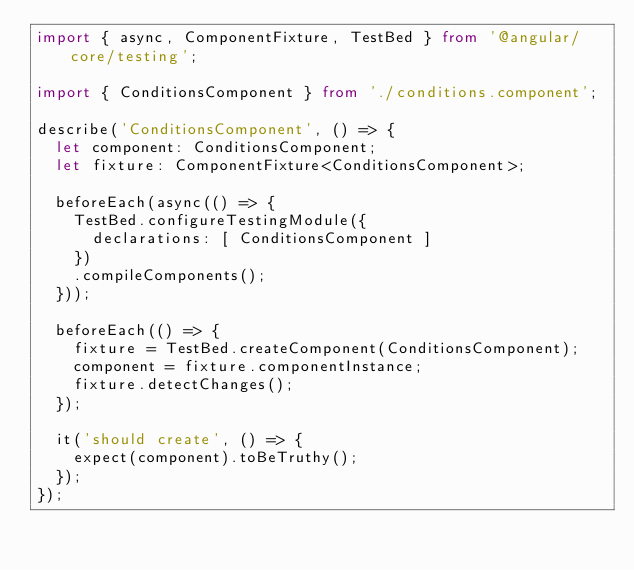<code> <loc_0><loc_0><loc_500><loc_500><_TypeScript_>import { async, ComponentFixture, TestBed } from '@angular/core/testing';

import { ConditionsComponent } from './conditions.component';

describe('ConditionsComponent', () => {
  let component: ConditionsComponent;
  let fixture: ComponentFixture<ConditionsComponent>;

  beforeEach(async(() => {
    TestBed.configureTestingModule({
      declarations: [ ConditionsComponent ]
    })
    .compileComponents();
  }));

  beforeEach(() => {
    fixture = TestBed.createComponent(ConditionsComponent);
    component = fixture.componentInstance;
    fixture.detectChanges();
  });

  it('should create', () => {
    expect(component).toBeTruthy();
  });
});
</code> 